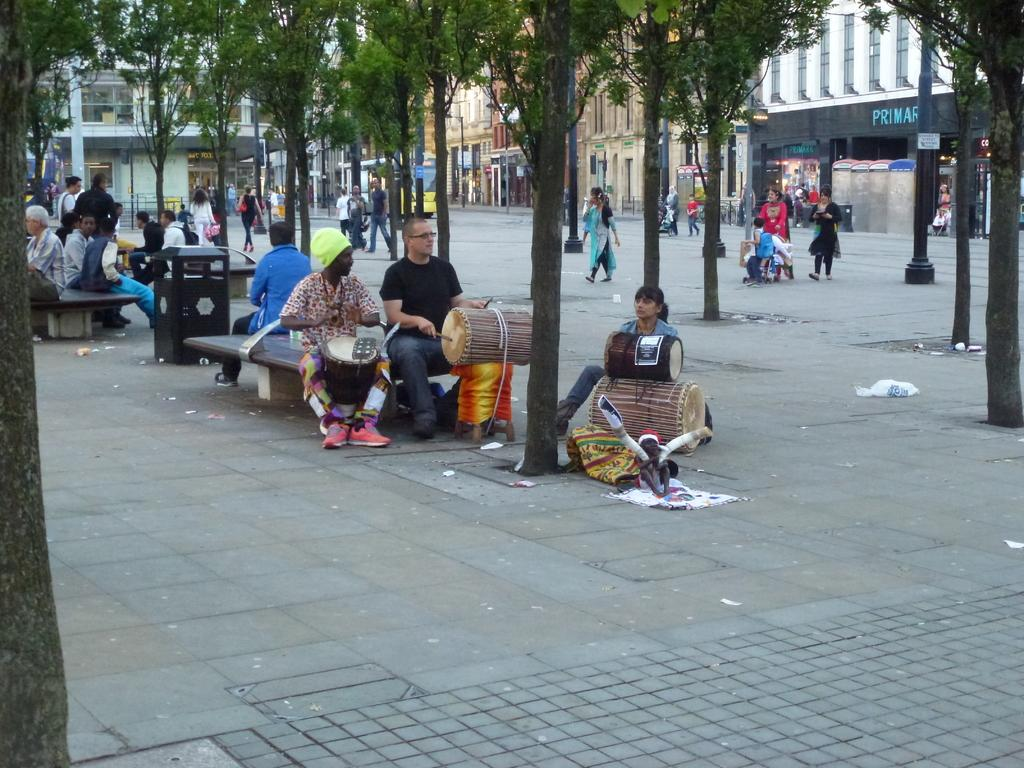What are the people in the image doing? The people in the image are sitting. What are the people holding? The people are holding drums. Can you describe the background of the image? There are other people, a tree, and buildings in the background of the image. What type of silk fabric is draped over the trail in the image? There is no silk fabric or trail present in the image. 